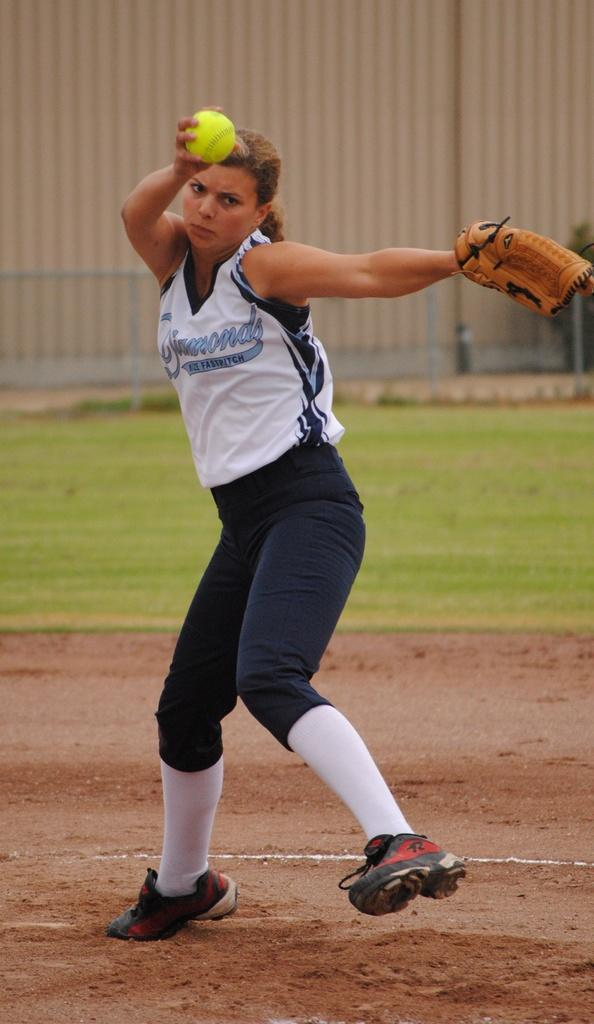<image>
Summarize the visual content of the image. A female baseball player with the words "fast pitch" on her shirt 